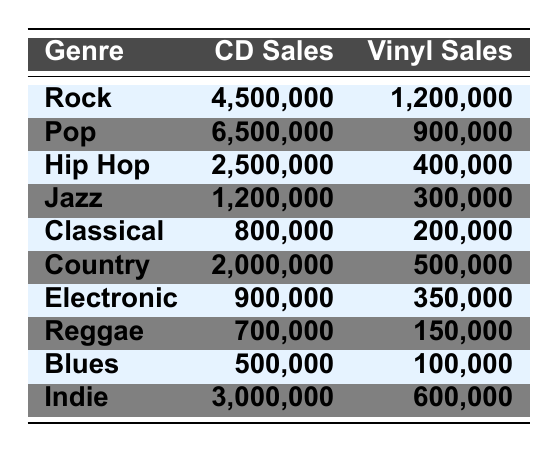What genre had the highest CD sales in 2022? Looking at the table, the genre with the highest CD sales is Pop, which had 6,500,000 CD sales.
Answer: Pop How many vinyl sales did Jazz have compared to Classical? Jazz had 300,000 vinyl sales and Classical had 200,000 vinyl sales. The difference is 300,000 - 200,000 = 100,000 more vinyl sales for Jazz.
Answer: 100,000 What is the total number of CD sales across all genres? Adding the CD sales from each genre: 4,500,000 + 6,500,000 + 2,500,000 + 1,200,000 + 800,000 + 2,000,000 + 900,000 + 700,000 + 500,000 + 3,000,000 = 22,600,000 CD sales in total.
Answer: 22,600,000 Did more vinyl albums sell in Rock or Country? Rock had 1,200,000 vinyl sales and Country had 500,000 vinyl sales. Since 1,200,000 is greater than 500,000, Rock had more vinyl sales than Country.
Answer: Yes What is the average number of CD sales per genre? There are 10 genres in total. The sum of CD sales is 22,600,000. Therefore, the average is 22,600,000 / 10 = 2,260,000 CD sales per genre.
Answer: 2,260,000 Which genres combined had more than 5 million CD sales? By analyzing the sales, Pop (6,500,000) and Rock (4,500,000) exceed 5 million individually. When we add Pop and Rock, 6,500,000 + 4,500,000 = 11,000,000, which is over 5 million. Other genres do not add up to exceed the threshold with any pair.
Answer: Pop and Rock How many more vinyl records were sold in the Indie genre than in the Reggae genre? Indie had 600,000 vinyl sales while Reggae had 150,000 vinyl sales. The difference is 600,000 - 150,000 = 450,000 more vinyl records sold in Indie.
Answer: 450,000 What percentage of total CD sales does Hip Hop represent? The total CD sales is 22,600,000 and Hip Hop sales were 2,500,000. The percentage is (2,500,000 / 22,600,000) * 100 ≈ 11.06%.
Answer: Approximately 11.06% Which genre had the lowest vinyl sales? Looking at the table, Blues had the lowest vinyl sales at 100,000.
Answer: Blues Are vinyl sales greater in Country compared to Hip Hop? Country had 500,000 vinyl sales, whereas Hip Hop had 400,000 vinyl sales. Since 500,000 is greater than 400,000, Country has more vinyl sales.
Answer: Yes 